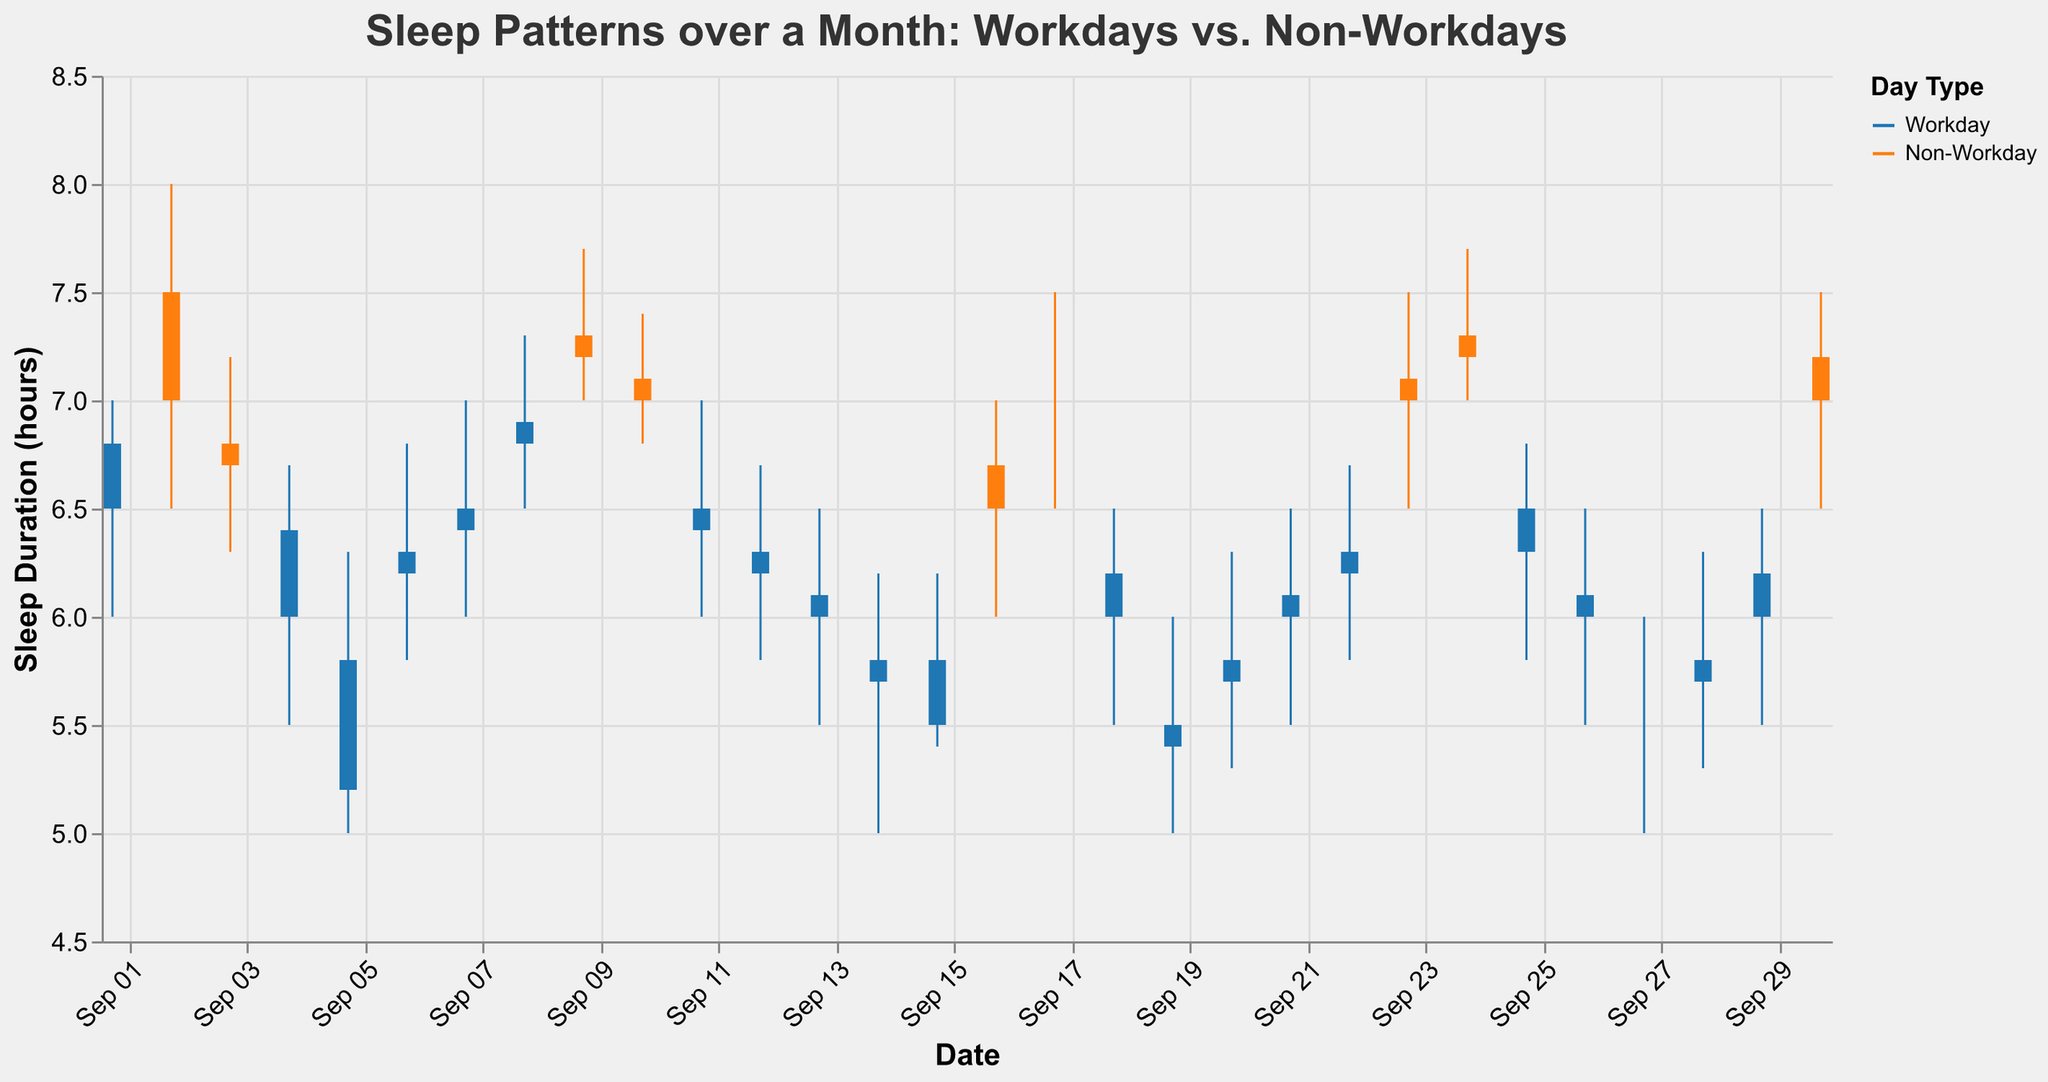What's the average sleep duration on non-workdays? The sleep durations on non-workdays are 7.5, 6.7, 7.3, 7.1, 6.7, 7.0, 7.1, 7.3, and 7.2. Adding them together gives 63.9. There are 9 non-workdays, so the average sleep duration is 63.9/9.
Answer: 7.1 hours Which day had the highest sleep duration? By looking at the "High" values, the highest value is 8.0 hours, which occurred on September 2.
Answer: September 2 Which day had the lowest quality of sleep on workdays and non-workdays? From the "Quality" column, the lowest quality on workdays is "Poor," which occurred on multiple days (e.g., September 5, September 14, September 15, September 19, September 20, and September 27). The lowest quality on non-workdays was "Good" which occurred on September 3, September 10, and September 16.
Answer: September 5, September 14, September 15, September 19, September 20, September 27 for workdays; September 3, September 10, September 16 for non-workdays On which days did sleep quality improve from a workday to the following non-workday? Sleep quality improved from September 15 (Poor) to September 16 (Good) and from September 29 (Moderate) to September 30 (Very Good).
Answer: September 16, September 30 How many days show a "Poor" quality of sleep? By counting the number of "Poor" entries in the "Quality" column, we find six days with "Poor" sleep.
Answer: 6 days Compare the average sleep duration on workdays versus non-workdays. Calculating the average for workdays: (6.8 + 6.4 + 5.2 + 6.2 + 6.4 + 6.9 + 6.4 + 6.2 + 6.1 + 5.8 + 5.5 + 6.2 + 5.4 + 5.7 + 6.1 + 6.3 + 6.5 + 6.1 + 5.5 + 5.7 + 6.2) / 21 = 127.7 / 21 ≈ 6.08. For non-workdays: (7.5 + 6.7 + 7.3 + 7.1 + 6.7 + 7.0 + 7.1 + 7.3 + 7.2) / 9 = 63.9 / 9 ≈ 7.1
Answer: 6.08 hours vs. 7.1 hours What is the range of sleep duration over the month? The range of sleep duration is defined by the lowest Low value to the highest High value. The lowest Low is 5.0 hours on multiple days, and the highest High is 8.0 hours on September 2. Therefore, the range is 8.0 - 5.0.
Answer: 3 hours What is the pattern of sleep quality on workdays towards the end of the month? The pattern of sleep quality from September 25 to September 29 is Good, Moderate, Poor, Poor, and Moderate.
Answer: Good, Moderate, Poor, Poor, Moderate Which non-workday had the best sleep quality and what was the duration? The best sleep quality on non-workdays is "Very Good." The days with "Very Good" are September 2, September 9, September 17, September 23, September 24, and September 30, with the sleep durations being 7.5 hours, 7.3 hours, 7.0 hours, 7.1 hours, 7.3 hours, and 7.2 hours respectively. The longest duration is 7.5 hours on September 2.
Answer: September 2, 7.5 hours 